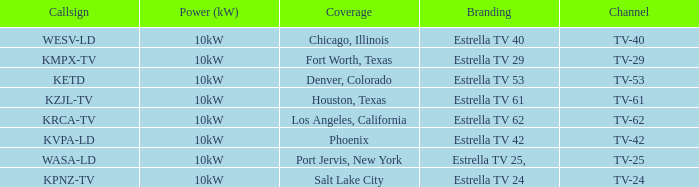List the branding for krca-tv. Estrella TV 62. 